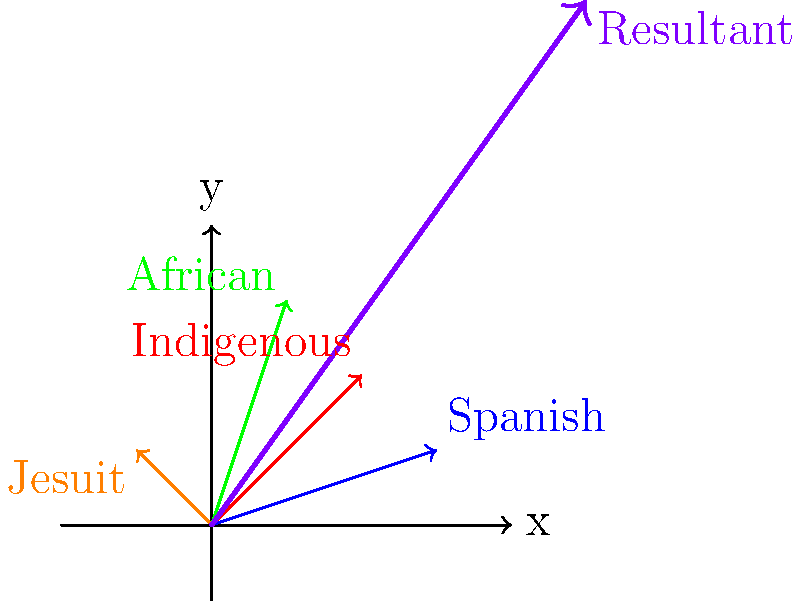In the context of colonial Mexican society, different cultural influences can be represented as vectors. Given the following vectors representing cultural influences:

Spanish: $\vec{v_1} = (3,1)$
Indigenous: $\vec{v_2} = (2,2)$
African: $\vec{v_3} = (1,3)$
Jesuit: $\vec{v_4} = (-1,1)$

Calculate the resultant vector that represents the combined impact of these cultural influences on colonial Mexican society. What is the magnitude of this resultant vector, rounded to two decimal places? To solve this problem, we'll follow these steps:

1. Add all the vectors to find the resultant vector:
   $\vec{R} = \vec{v_1} + \vec{v_2} + \vec{v_3} + \vec{v_4}$
   $\vec{R} = (3,1) + (2,2) + (1,3) + (-1,1)$
   $\vec{R} = (3+2+1-1, 1+2+3+1)$
   $\vec{R} = (5,7)$

2. Calculate the magnitude of the resultant vector using the Pythagorean theorem:
   $|\vec{R}| = \sqrt{x^2 + y^2}$
   $|\vec{R}| = \sqrt{5^2 + 7^2}$
   $|\vec{R}| = \sqrt{25 + 49}$
   $|\vec{R}| = \sqrt{74}$
   $|\vec{R}| \approx 8.60$

3. Round the result to two decimal places:
   $|\vec{R}| \approx 8.60$

This resultant vector $(5,7)$ with a magnitude of 8.60 represents the combined impact of Spanish, Indigenous, African, and Jesuit influences on colonial Mexican society. The larger y-component suggests a stronger vertical (possibly spiritual or social) influence, while the x-component represents horizontal (possibly political or economic) influence.
Answer: 8.60 